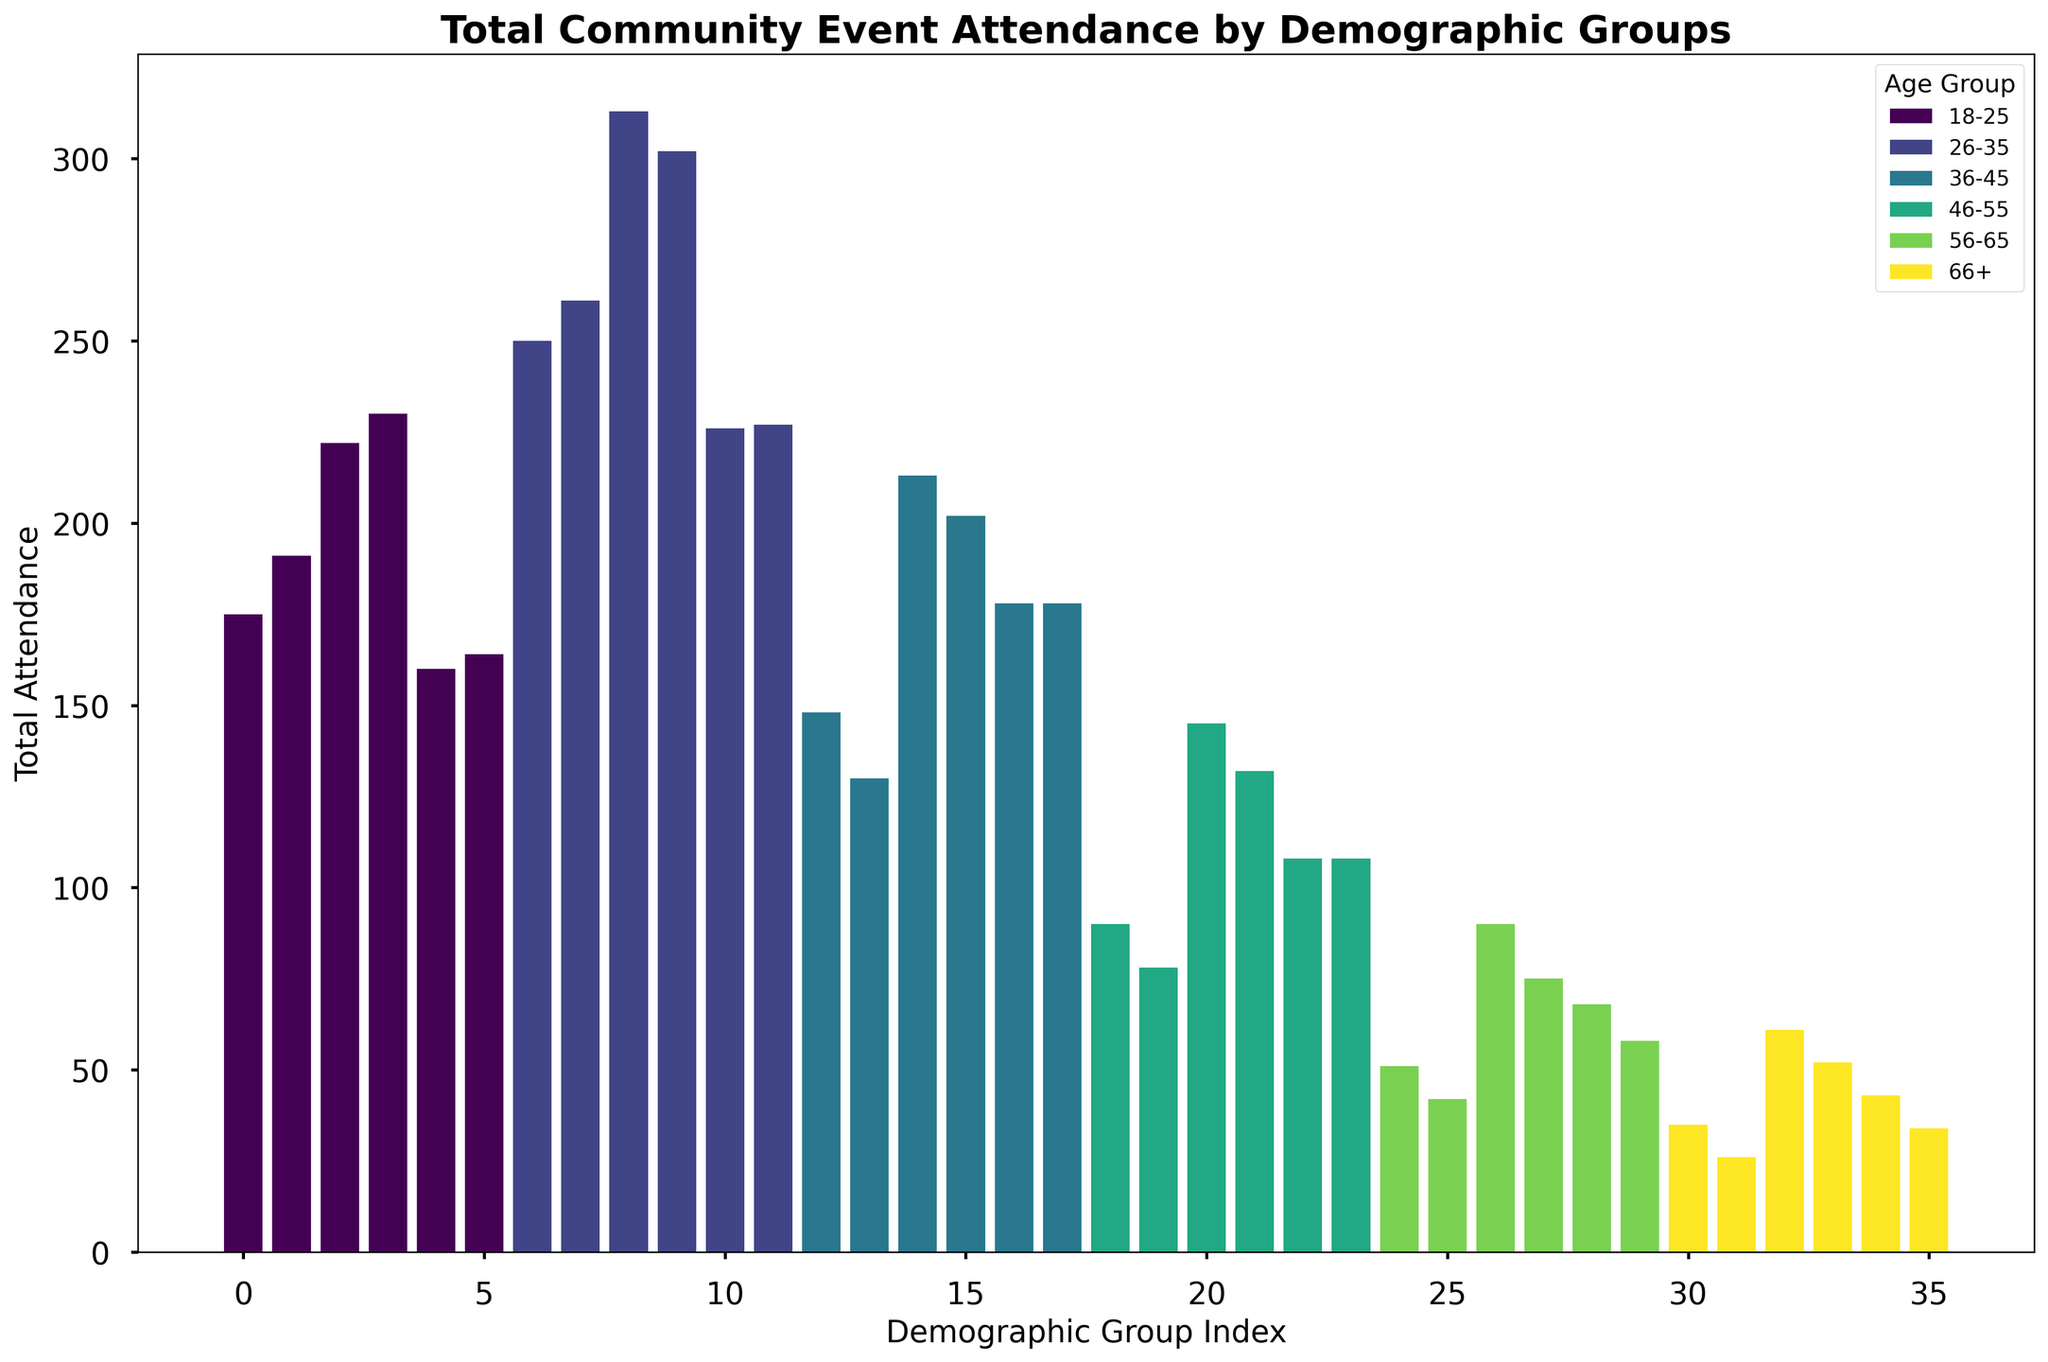What's the age group with the highest total attendance? We need to locate the tallest bar on the histogram, which represents the highest total attendance, then check the color legend to determine the corresponding age group.
Answer: 26-35 What's the total attendance for the age group 66+M? Find the position of the bar corresponding to the demographic group 66+M and read the height of the bar which represents the total attendance.
Answer: 35 Which gender in the age group 18-25 has higher attendance, and by how much? Compare the total attendance bars for males and females in the 18-25 age group by checking their height and subtracting the smaller value from the larger one.
Answer: Female, by 15 How does total attendance of low-income bracket in the age group 36-45 compare to the medium-income bracket in the same age group? Identify the bars for the demographic groups 36-45, low-income and 36-45, medium-income, compare their heights directly.
Answer: Medium income is higher What is the difference in total attendance between the 56-65 age group and the 46-55 age group? Calculate the total attendance for each demographic by summing the heights of the corresponding bars and then subtracting the total of the younger age group from the older one.
Answer: 56-65 is lower by 110 What is the average total attendance for the 26-35 age group? Sum up the total attendance values for all subgroups (combined all genders and income brackets) in 26-35 and divide by the number of subgroups within this age group.
Answer: 69.5 Which age group has the least total attendance, and what is that value? Locate the shortest bar on the histogram and refer to the color legend to find the corresponding age group and read its value.
Answer: 66+, 35 How does the total attendance of males compare to females within the age group 18-25? Identify and sum the heights of all male and female bars within the 18-25 age group, then compare the two sums.
Answer: Females higher by 10 